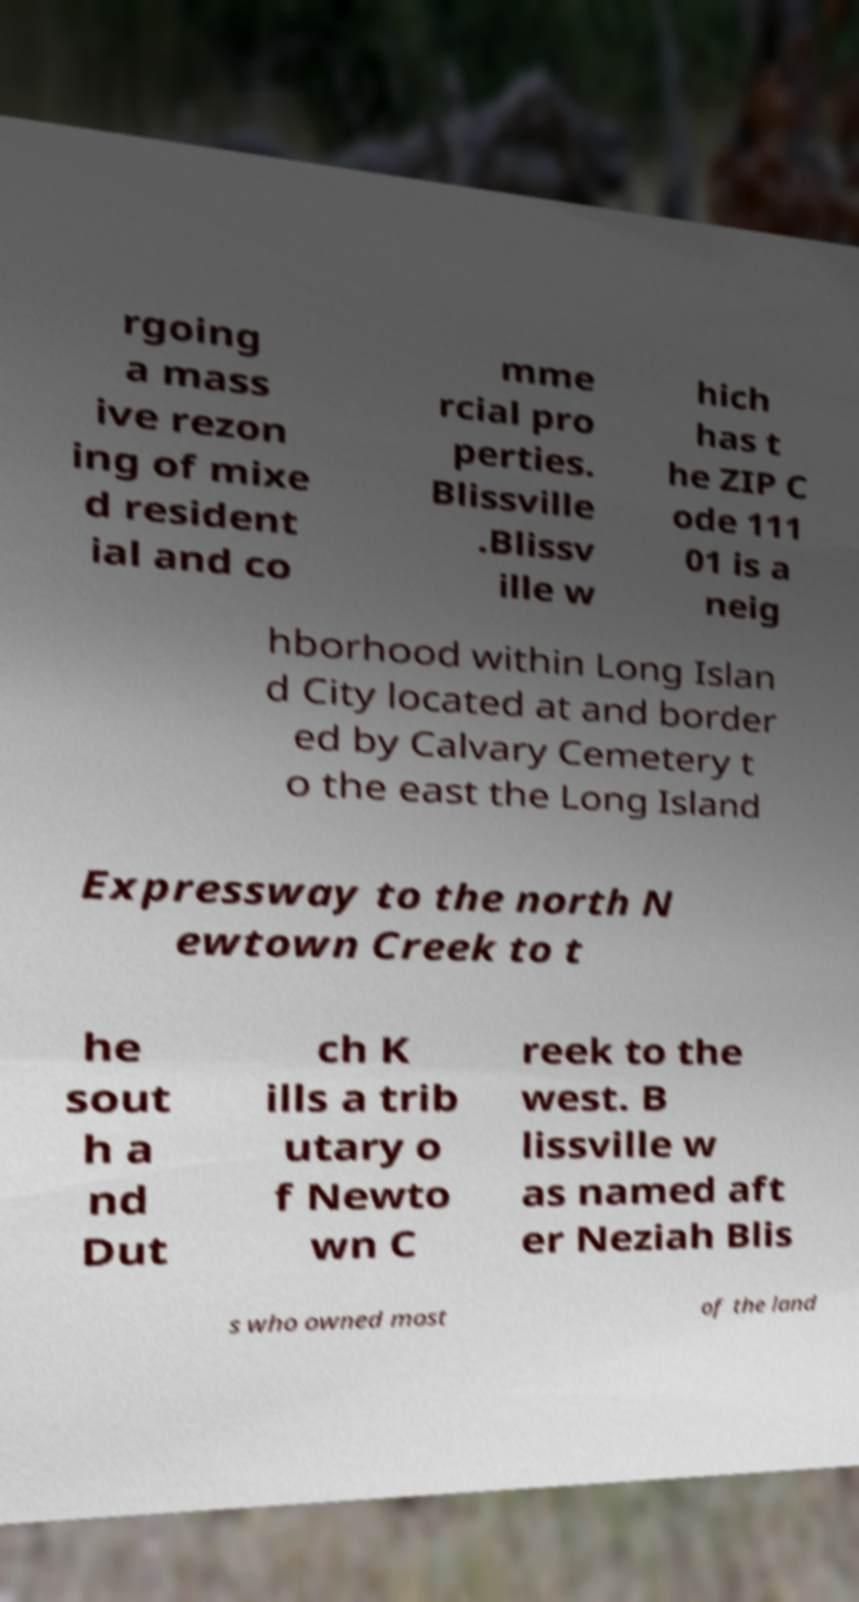Please identify and transcribe the text found in this image. rgoing a mass ive rezon ing of mixe d resident ial and co mme rcial pro perties. Blissville .Blissv ille w hich has t he ZIP C ode 111 01 is a neig hborhood within Long Islan d City located at and border ed by Calvary Cemetery t o the east the Long Island Expressway to the north N ewtown Creek to t he sout h a nd Dut ch K ills a trib utary o f Newto wn C reek to the west. B lissville w as named aft er Neziah Blis s who owned most of the land 